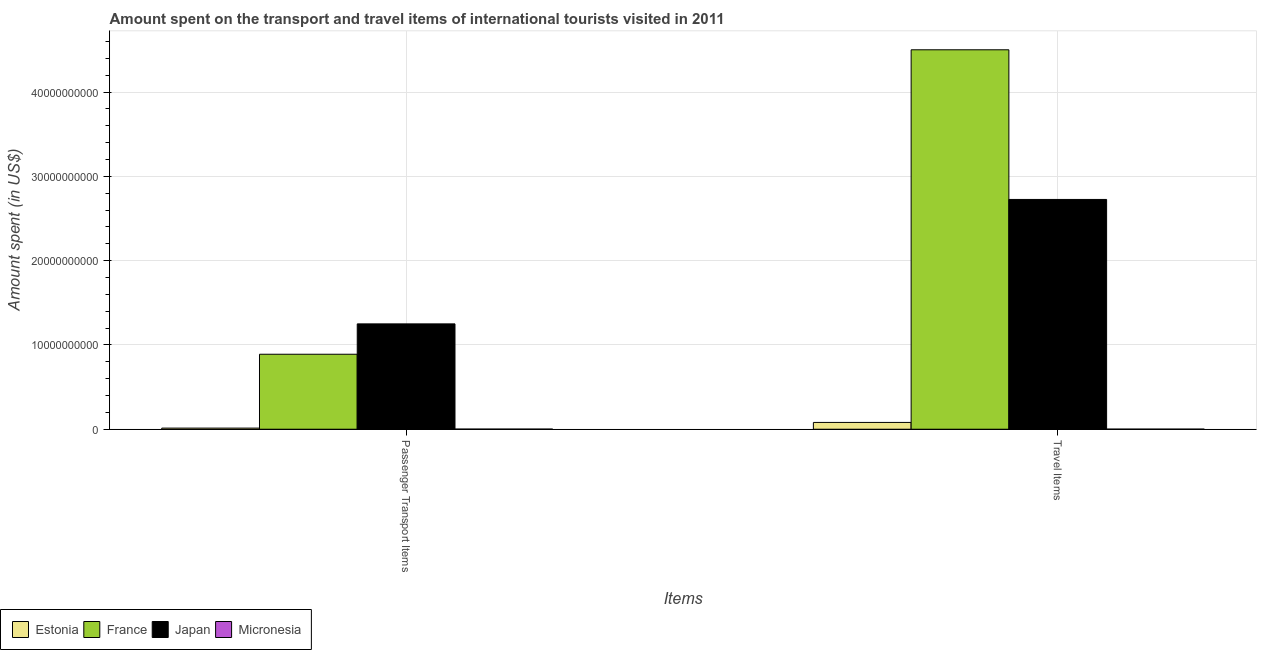How many different coloured bars are there?
Offer a terse response. 4. Are the number of bars per tick equal to the number of legend labels?
Provide a succinct answer. Yes. Are the number of bars on each tick of the X-axis equal?
Give a very brief answer. Yes. How many bars are there on the 1st tick from the left?
Keep it short and to the point. 4. What is the label of the 2nd group of bars from the left?
Make the answer very short. Travel Items. What is the amount spent in travel items in Estonia?
Keep it short and to the point. 8.06e+08. Across all countries, what is the maximum amount spent on passenger transport items?
Provide a short and direct response. 1.25e+1. Across all countries, what is the minimum amount spent on passenger transport items?
Ensure brevity in your answer.  1.50e+07. In which country was the amount spent on passenger transport items maximum?
Provide a succinct answer. Japan. In which country was the amount spent on passenger transport items minimum?
Ensure brevity in your answer.  Micronesia. What is the total amount spent on passenger transport items in the graph?
Give a very brief answer. 2.15e+1. What is the difference between the amount spent in travel items in Micronesia and that in Japan?
Keep it short and to the point. -2.72e+1. What is the difference between the amount spent on passenger transport items in Estonia and the amount spent in travel items in Micronesia?
Your response must be concise. 1.21e+08. What is the average amount spent on passenger transport items per country?
Make the answer very short. 5.39e+09. What is the difference between the amount spent on passenger transport items and amount spent in travel items in Japan?
Your answer should be very brief. -1.48e+1. In how many countries, is the amount spent on passenger transport items greater than 42000000000 US$?
Offer a terse response. 0. What is the ratio of the amount spent in travel items in Micronesia to that in Japan?
Offer a terse response. 0. Is the amount spent in travel items in Micronesia less than that in Japan?
Your response must be concise. Yes. What does the 4th bar from the left in Passenger Transport Items represents?
Provide a succinct answer. Micronesia. What does the 2nd bar from the right in Travel Items represents?
Make the answer very short. Japan. How many bars are there?
Ensure brevity in your answer.  8. Are all the bars in the graph horizontal?
Provide a short and direct response. No. Does the graph contain grids?
Offer a very short reply. Yes. How many legend labels are there?
Offer a very short reply. 4. How are the legend labels stacked?
Offer a very short reply. Horizontal. What is the title of the graph?
Provide a succinct answer. Amount spent on the transport and travel items of international tourists visited in 2011. Does "Belarus" appear as one of the legend labels in the graph?
Give a very brief answer. No. What is the label or title of the X-axis?
Provide a succinct answer. Items. What is the label or title of the Y-axis?
Provide a succinct answer. Amount spent (in US$). What is the Amount spent (in US$) of Estonia in Passenger Transport Items?
Your answer should be compact. 1.33e+08. What is the Amount spent (in US$) of France in Passenger Transport Items?
Your answer should be compact. 8.90e+09. What is the Amount spent (in US$) of Japan in Passenger Transport Items?
Offer a terse response. 1.25e+1. What is the Amount spent (in US$) of Micronesia in Passenger Transport Items?
Ensure brevity in your answer.  1.50e+07. What is the Amount spent (in US$) in Estonia in Travel Items?
Offer a very short reply. 8.06e+08. What is the Amount spent (in US$) in France in Travel Items?
Give a very brief answer. 4.50e+1. What is the Amount spent (in US$) in Japan in Travel Items?
Make the answer very short. 2.73e+1. What is the Amount spent (in US$) of Micronesia in Travel Items?
Offer a very short reply. 1.20e+07. Across all Items, what is the maximum Amount spent (in US$) of Estonia?
Offer a terse response. 8.06e+08. Across all Items, what is the maximum Amount spent (in US$) of France?
Ensure brevity in your answer.  4.50e+1. Across all Items, what is the maximum Amount spent (in US$) of Japan?
Your response must be concise. 2.73e+1. Across all Items, what is the maximum Amount spent (in US$) in Micronesia?
Your answer should be very brief. 1.50e+07. Across all Items, what is the minimum Amount spent (in US$) of Estonia?
Your response must be concise. 1.33e+08. Across all Items, what is the minimum Amount spent (in US$) of France?
Offer a terse response. 8.90e+09. Across all Items, what is the minimum Amount spent (in US$) in Japan?
Ensure brevity in your answer.  1.25e+1. What is the total Amount spent (in US$) in Estonia in the graph?
Provide a short and direct response. 9.39e+08. What is the total Amount spent (in US$) of France in the graph?
Provide a short and direct response. 5.39e+1. What is the total Amount spent (in US$) of Japan in the graph?
Offer a very short reply. 3.98e+1. What is the total Amount spent (in US$) in Micronesia in the graph?
Ensure brevity in your answer.  2.70e+07. What is the difference between the Amount spent (in US$) in Estonia in Passenger Transport Items and that in Travel Items?
Your answer should be very brief. -6.73e+08. What is the difference between the Amount spent (in US$) in France in Passenger Transport Items and that in Travel Items?
Your response must be concise. -3.61e+1. What is the difference between the Amount spent (in US$) in Japan in Passenger Transport Items and that in Travel Items?
Your answer should be compact. -1.48e+1. What is the difference between the Amount spent (in US$) of Micronesia in Passenger Transport Items and that in Travel Items?
Offer a very short reply. 3.00e+06. What is the difference between the Amount spent (in US$) in Estonia in Passenger Transport Items and the Amount spent (in US$) in France in Travel Items?
Provide a succinct answer. -4.49e+1. What is the difference between the Amount spent (in US$) of Estonia in Passenger Transport Items and the Amount spent (in US$) of Japan in Travel Items?
Offer a terse response. -2.71e+1. What is the difference between the Amount spent (in US$) in Estonia in Passenger Transport Items and the Amount spent (in US$) in Micronesia in Travel Items?
Ensure brevity in your answer.  1.21e+08. What is the difference between the Amount spent (in US$) of France in Passenger Transport Items and the Amount spent (in US$) of Japan in Travel Items?
Your answer should be compact. -1.84e+1. What is the difference between the Amount spent (in US$) in France in Passenger Transport Items and the Amount spent (in US$) in Micronesia in Travel Items?
Your response must be concise. 8.88e+09. What is the difference between the Amount spent (in US$) of Japan in Passenger Transport Items and the Amount spent (in US$) of Micronesia in Travel Items?
Offer a very short reply. 1.25e+1. What is the average Amount spent (in US$) in Estonia per Items?
Keep it short and to the point. 4.70e+08. What is the average Amount spent (in US$) in France per Items?
Keep it short and to the point. 2.70e+1. What is the average Amount spent (in US$) of Japan per Items?
Keep it short and to the point. 1.99e+1. What is the average Amount spent (in US$) of Micronesia per Items?
Keep it short and to the point. 1.35e+07. What is the difference between the Amount spent (in US$) of Estonia and Amount spent (in US$) of France in Passenger Transport Items?
Offer a very short reply. -8.76e+09. What is the difference between the Amount spent (in US$) in Estonia and Amount spent (in US$) in Japan in Passenger Transport Items?
Your answer should be compact. -1.24e+1. What is the difference between the Amount spent (in US$) of Estonia and Amount spent (in US$) of Micronesia in Passenger Transport Items?
Your answer should be compact. 1.18e+08. What is the difference between the Amount spent (in US$) of France and Amount spent (in US$) of Japan in Passenger Transport Items?
Give a very brief answer. -3.60e+09. What is the difference between the Amount spent (in US$) of France and Amount spent (in US$) of Micronesia in Passenger Transport Items?
Offer a very short reply. 8.88e+09. What is the difference between the Amount spent (in US$) of Japan and Amount spent (in US$) of Micronesia in Passenger Transport Items?
Ensure brevity in your answer.  1.25e+1. What is the difference between the Amount spent (in US$) in Estonia and Amount spent (in US$) in France in Travel Items?
Keep it short and to the point. -4.42e+1. What is the difference between the Amount spent (in US$) in Estonia and Amount spent (in US$) in Japan in Travel Items?
Give a very brief answer. -2.65e+1. What is the difference between the Amount spent (in US$) in Estonia and Amount spent (in US$) in Micronesia in Travel Items?
Your answer should be compact. 7.94e+08. What is the difference between the Amount spent (in US$) in France and Amount spent (in US$) in Japan in Travel Items?
Give a very brief answer. 1.78e+1. What is the difference between the Amount spent (in US$) of France and Amount spent (in US$) of Micronesia in Travel Items?
Make the answer very short. 4.50e+1. What is the difference between the Amount spent (in US$) of Japan and Amount spent (in US$) of Micronesia in Travel Items?
Your answer should be compact. 2.72e+1. What is the ratio of the Amount spent (in US$) in Estonia in Passenger Transport Items to that in Travel Items?
Offer a very short reply. 0.17. What is the ratio of the Amount spent (in US$) in France in Passenger Transport Items to that in Travel Items?
Give a very brief answer. 0.2. What is the ratio of the Amount spent (in US$) in Japan in Passenger Transport Items to that in Travel Items?
Provide a short and direct response. 0.46. What is the difference between the highest and the second highest Amount spent (in US$) of Estonia?
Give a very brief answer. 6.73e+08. What is the difference between the highest and the second highest Amount spent (in US$) in France?
Your response must be concise. 3.61e+1. What is the difference between the highest and the second highest Amount spent (in US$) in Japan?
Make the answer very short. 1.48e+1. What is the difference between the highest and the second highest Amount spent (in US$) in Micronesia?
Provide a short and direct response. 3.00e+06. What is the difference between the highest and the lowest Amount spent (in US$) in Estonia?
Offer a very short reply. 6.73e+08. What is the difference between the highest and the lowest Amount spent (in US$) in France?
Provide a short and direct response. 3.61e+1. What is the difference between the highest and the lowest Amount spent (in US$) in Japan?
Offer a very short reply. 1.48e+1. What is the difference between the highest and the lowest Amount spent (in US$) in Micronesia?
Ensure brevity in your answer.  3.00e+06. 